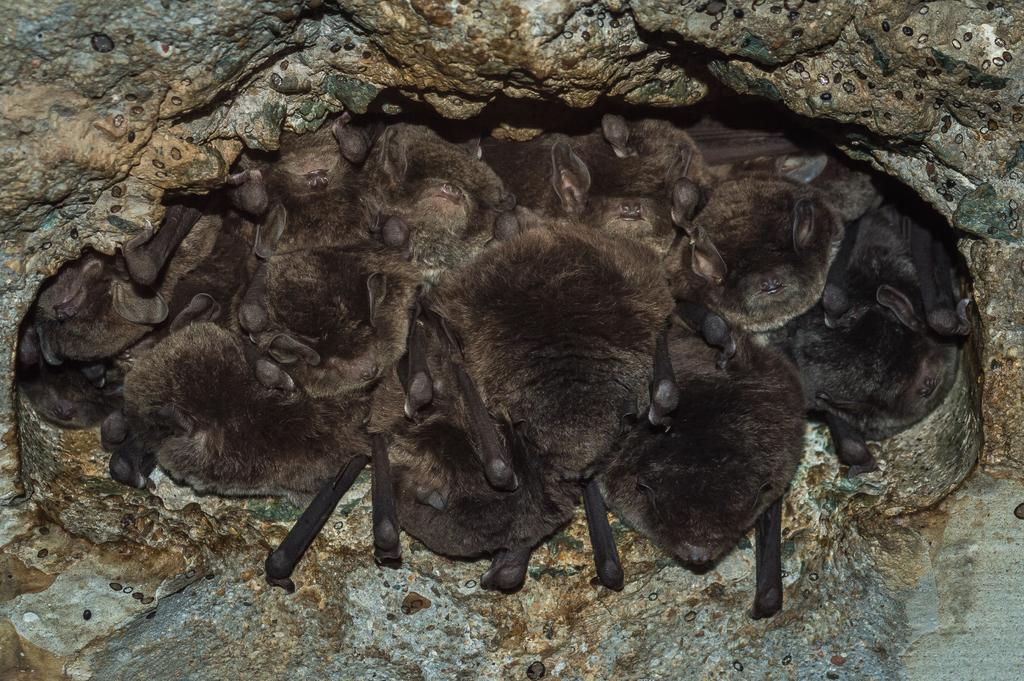What type of animals are in the image? There are bats in the image. What color are the bats? The bats are black in color. What can be seen in the background of the image? There is a rock in the background of the image. What type of fiction is the ladybug reading in the image? There is no ladybug or any reading material present in the image; it features bats and a rock. 